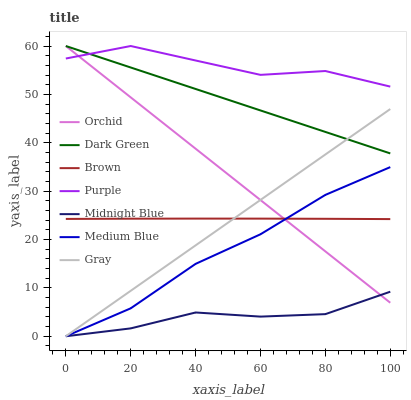Does Midnight Blue have the minimum area under the curve?
Answer yes or no. Yes. Does Purple have the maximum area under the curve?
Answer yes or no. Yes. Does Gray have the minimum area under the curve?
Answer yes or no. No. Does Gray have the maximum area under the curve?
Answer yes or no. No. Is Gray the smoothest?
Answer yes or no. Yes. Is Purple the roughest?
Answer yes or no. Yes. Is Midnight Blue the smoothest?
Answer yes or no. No. Is Midnight Blue the roughest?
Answer yes or no. No. Does Purple have the lowest value?
Answer yes or no. No. Does Dark Green have the highest value?
Answer yes or no. Yes. Does Gray have the highest value?
Answer yes or no. No. Is Midnight Blue less than Purple?
Answer yes or no. Yes. Is Dark Green greater than Brown?
Answer yes or no. Yes. Does Medium Blue intersect Brown?
Answer yes or no. Yes. Is Medium Blue less than Brown?
Answer yes or no. No. Is Medium Blue greater than Brown?
Answer yes or no. No. Does Midnight Blue intersect Purple?
Answer yes or no. No. 